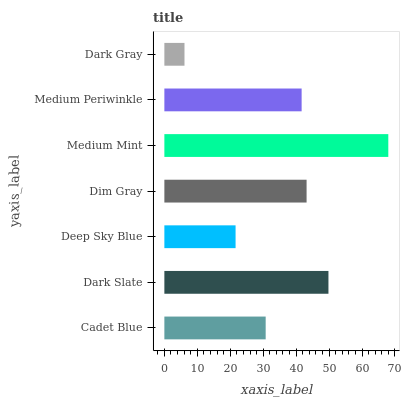Is Dark Gray the minimum?
Answer yes or no. Yes. Is Medium Mint the maximum?
Answer yes or no. Yes. Is Dark Slate the minimum?
Answer yes or no. No. Is Dark Slate the maximum?
Answer yes or no. No. Is Dark Slate greater than Cadet Blue?
Answer yes or no. Yes. Is Cadet Blue less than Dark Slate?
Answer yes or no. Yes. Is Cadet Blue greater than Dark Slate?
Answer yes or no. No. Is Dark Slate less than Cadet Blue?
Answer yes or no. No. Is Medium Periwinkle the high median?
Answer yes or no. Yes. Is Medium Periwinkle the low median?
Answer yes or no. Yes. Is Medium Mint the high median?
Answer yes or no. No. Is Dark Gray the low median?
Answer yes or no. No. 